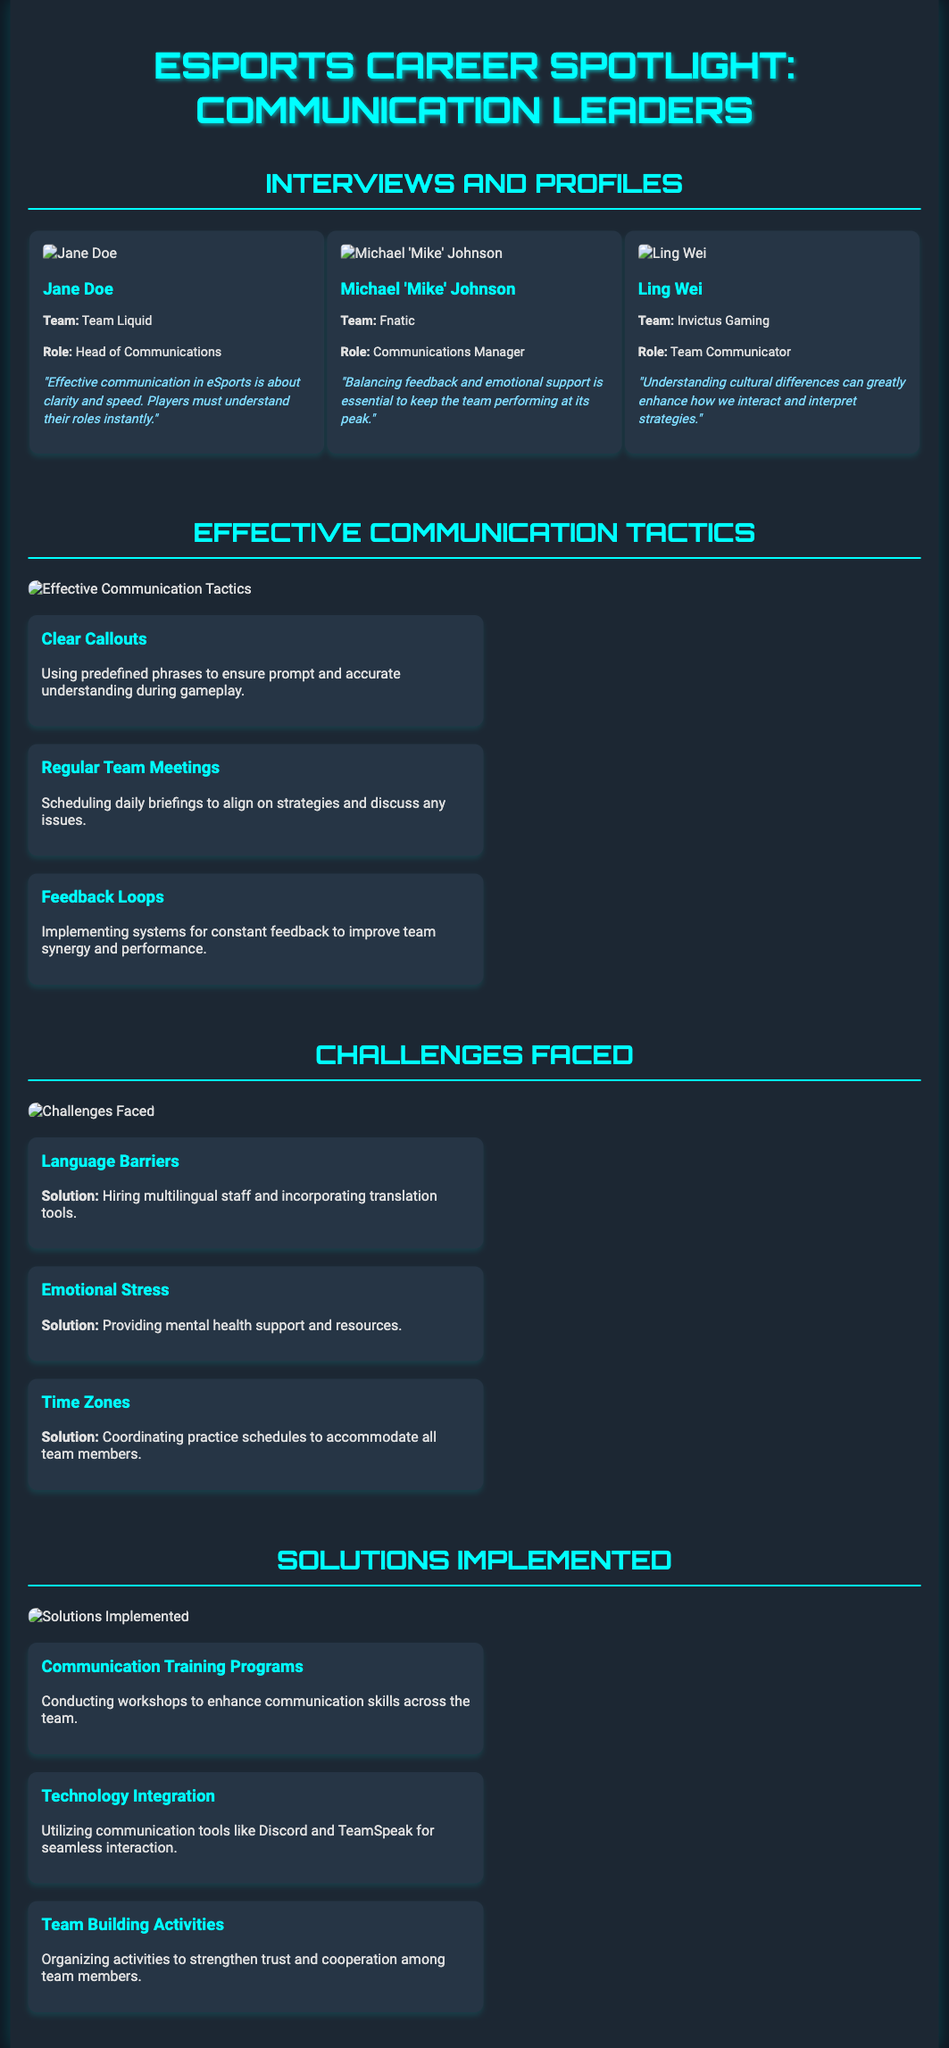What is the title of the document? The title is presented at the top of the document in large font.
Answer: eSports Career Spotlight: Communication Leaders Who is the Head of Communications for Team Liquid? The document includes a profile section where team roles are specified.
Answer: Jane Doe What role does Ling Wei hold in Invictus Gaming? The profile section provides specific titles for each individual in their respective teams.
Answer: Team Communicator What is one effective communication tactic mentioned in the document? The section on effective communication tactics lists several strategies.
Answer: Clear Callouts What challenge related to time zones is mentioned? The challenges section outlines specific difficulties teams face.
Answer: Time Zones What is a solution for emotional stress in eSports teams? Each challenge listed has an associated solution outlined in the text.
Answer: Providing mental health support and resources How many percent of the profiles are female? The profiles section includes three individuals, and counting their genders allows for this analysis.
Answer: 33% Which communication tool is mentioned for seamless interaction? The solutions implemented section specifies technology used in team communication.
Answer: Discord What type of activities are organized to strengthen trust among team members? The solutions implemented section details specific actions taken for team building.
Answer: Team Building Activities 